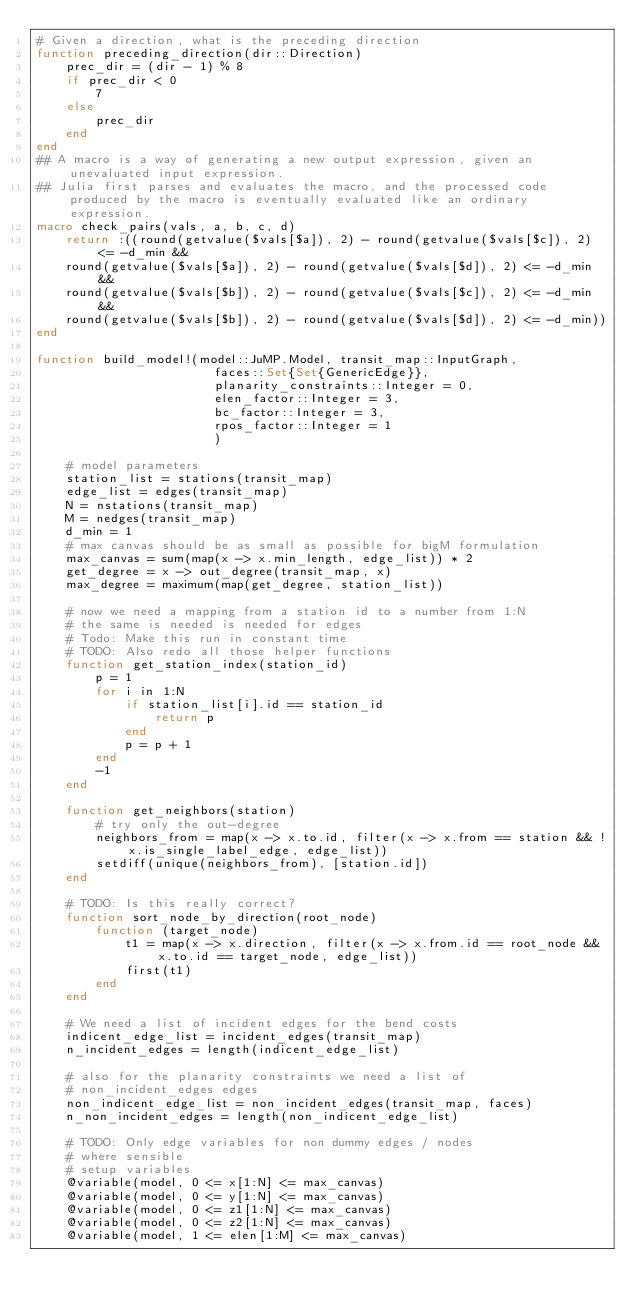Convert code to text. <code><loc_0><loc_0><loc_500><loc_500><_Julia_># Given a direction, what is the preceding direction
function preceding_direction(dir::Direction)
    prec_dir = (dir - 1) % 8
    if prec_dir < 0
        7
    else
        prec_dir
    end
end
## A macro is a way of generating a new output expression, given an unevaluated input expression.
## Julia first parses and evaluates the macro, and the processed code produced by the macro is eventually evaluated like an ordinary expression.
macro check_pairs(vals, a, b, c, d)
    return :((round(getvalue($vals[$a]), 2) - round(getvalue($vals[$c]), 2) <= -d_min &&
    round(getvalue($vals[$a]), 2) - round(getvalue($vals[$d]), 2) <= -d_min &&
    round(getvalue($vals[$b]), 2) - round(getvalue($vals[$c]), 2) <= -d_min &&
    round(getvalue($vals[$b]), 2) - round(getvalue($vals[$d]), 2) <= -d_min))
end

function build_model!(model::JuMP.Model, transit_map::InputGraph,
                        faces::Set{Set{GenericEdge}},
                        planarity_constraints::Integer = 0,
                        elen_factor::Integer = 3,
                        bc_factor::Integer = 3,
                        rpos_factor::Integer = 1
                        )

    # model parameters
    station_list = stations(transit_map)
    edge_list = edges(transit_map)
    N = nstations(transit_map)
    M = nedges(transit_map)
    d_min = 1
    # max canvas should be as small as possible for bigM formulation
    max_canvas = sum(map(x -> x.min_length, edge_list)) * 2
    get_degree = x -> out_degree(transit_map, x)
    max_degree = maximum(map(get_degree, station_list))

    # now we need a mapping from a station id to a number from 1:N
    # the same is needed is needed for edges
    # Todo: Make this run in constant time
    # TODO: Also redo all those helper functions
    function get_station_index(station_id)
        p = 1
        for i in 1:N
            if station_list[i].id == station_id
                return p
            end
            p = p + 1
        end
        -1
    end

    function get_neighbors(station)
        # try only the out-degree
        neighbors_from = map(x -> x.to.id, filter(x -> x.from == station && !x.is_single_label_edge, edge_list))
        setdiff(unique(neighbors_from), [station.id])
    end

    # TODO: Is this really correct?
    function sort_node_by_direction(root_node)
        function (target_node)
            t1 = map(x -> x.direction, filter(x -> x.from.id == root_node && x.to.id == target_node, edge_list))
            first(t1)
        end
    end

    # We need a list of incident edges for the bend costs
    indicent_edge_list = incident_edges(transit_map)
    n_incident_edges = length(indicent_edge_list)

    # also for the planarity constraints we need a list of
    # non_incident_edges edges
    non_indicent_edge_list = non_incident_edges(transit_map, faces)
    n_non_incident_edges = length(non_indicent_edge_list)

    # TODO: Only edge variables for non dummy edges / nodes
    # where sensible
    # setup variables
    @variable(model, 0 <= x[1:N] <= max_canvas)
    @variable(model, 0 <= y[1:N] <= max_canvas)
    @variable(model, 0 <= z1[1:N] <= max_canvas)
    @variable(model, 0 <= z2[1:N] <= max_canvas)
    @variable(model, 1 <= elen[1:M] <= max_canvas)</code> 